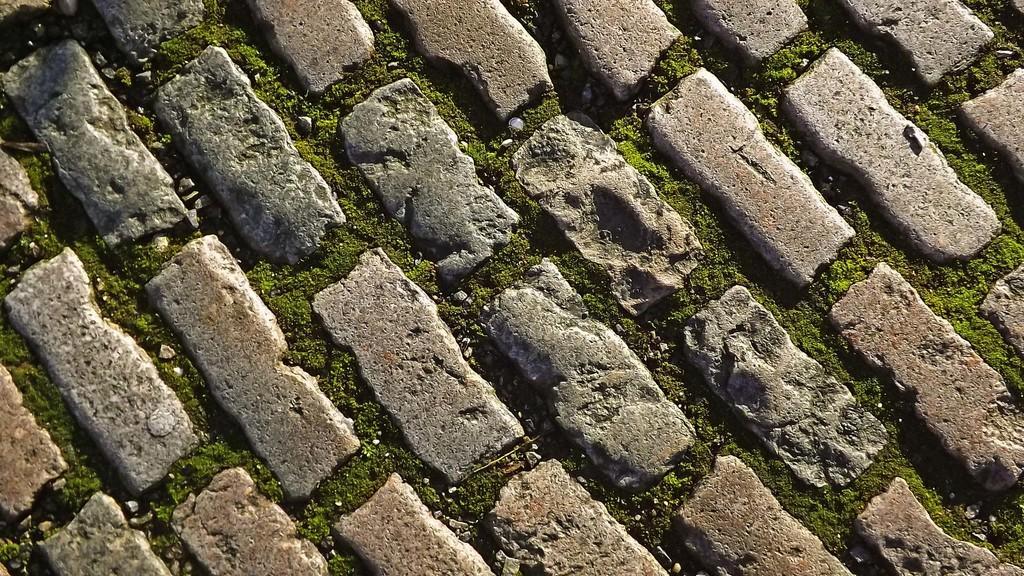How would you summarize this image in a sentence or two? In this picture, we see the grass, cobblestones and small stones. This picture might be the pavement. 